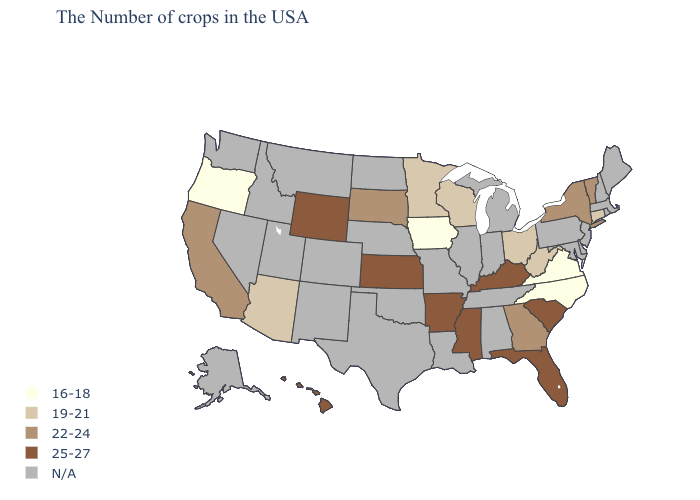Among the states that border Alabama , which have the highest value?
Write a very short answer. Florida, Mississippi. Name the states that have a value in the range N/A?
Give a very brief answer. Maine, Massachusetts, Rhode Island, New Hampshire, New Jersey, Delaware, Maryland, Pennsylvania, Michigan, Indiana, Alabama, Tennessee, Illinois, Louisiana, Missouri, Nebraska, Oklahoma, Texas, North Dakota, Colorado, New Mexico, Utah, Montana, Idaho, Nevada, Washington, Alaska. Name the states that have a value in the range 16-18?
Short answer required. Virginia, North Carolina, Iowa, Oregon. Does the first symbol in the legend represent the smallest category?
Keep it brief. Yes. Does the map have missing data?
Answer briefly. Yes. What is the lowest value in states that border Wyoming?
Write a very short answer. 22-24. What is the value of Iowa?
Write a very short answer. 16-18. What is the lowest value in the West?
Answer briefly. 16-18. Does the map have missing data?
Quick response, please. Yes. Among the states that border Nebraska , which have the lowest value?
Be succinct. Iowa. What is the highest value in the USA?
Answer briefly. 25-27. What is the value of Indiana?
Give a very brief answer. N/A. What is the highest value in the Northeast ?
Give a very brief answer. 22-24. Name the states that have a value in the range 16-18?
Be succinct. Virginia, North Carolina, Iowa, Oregon. 